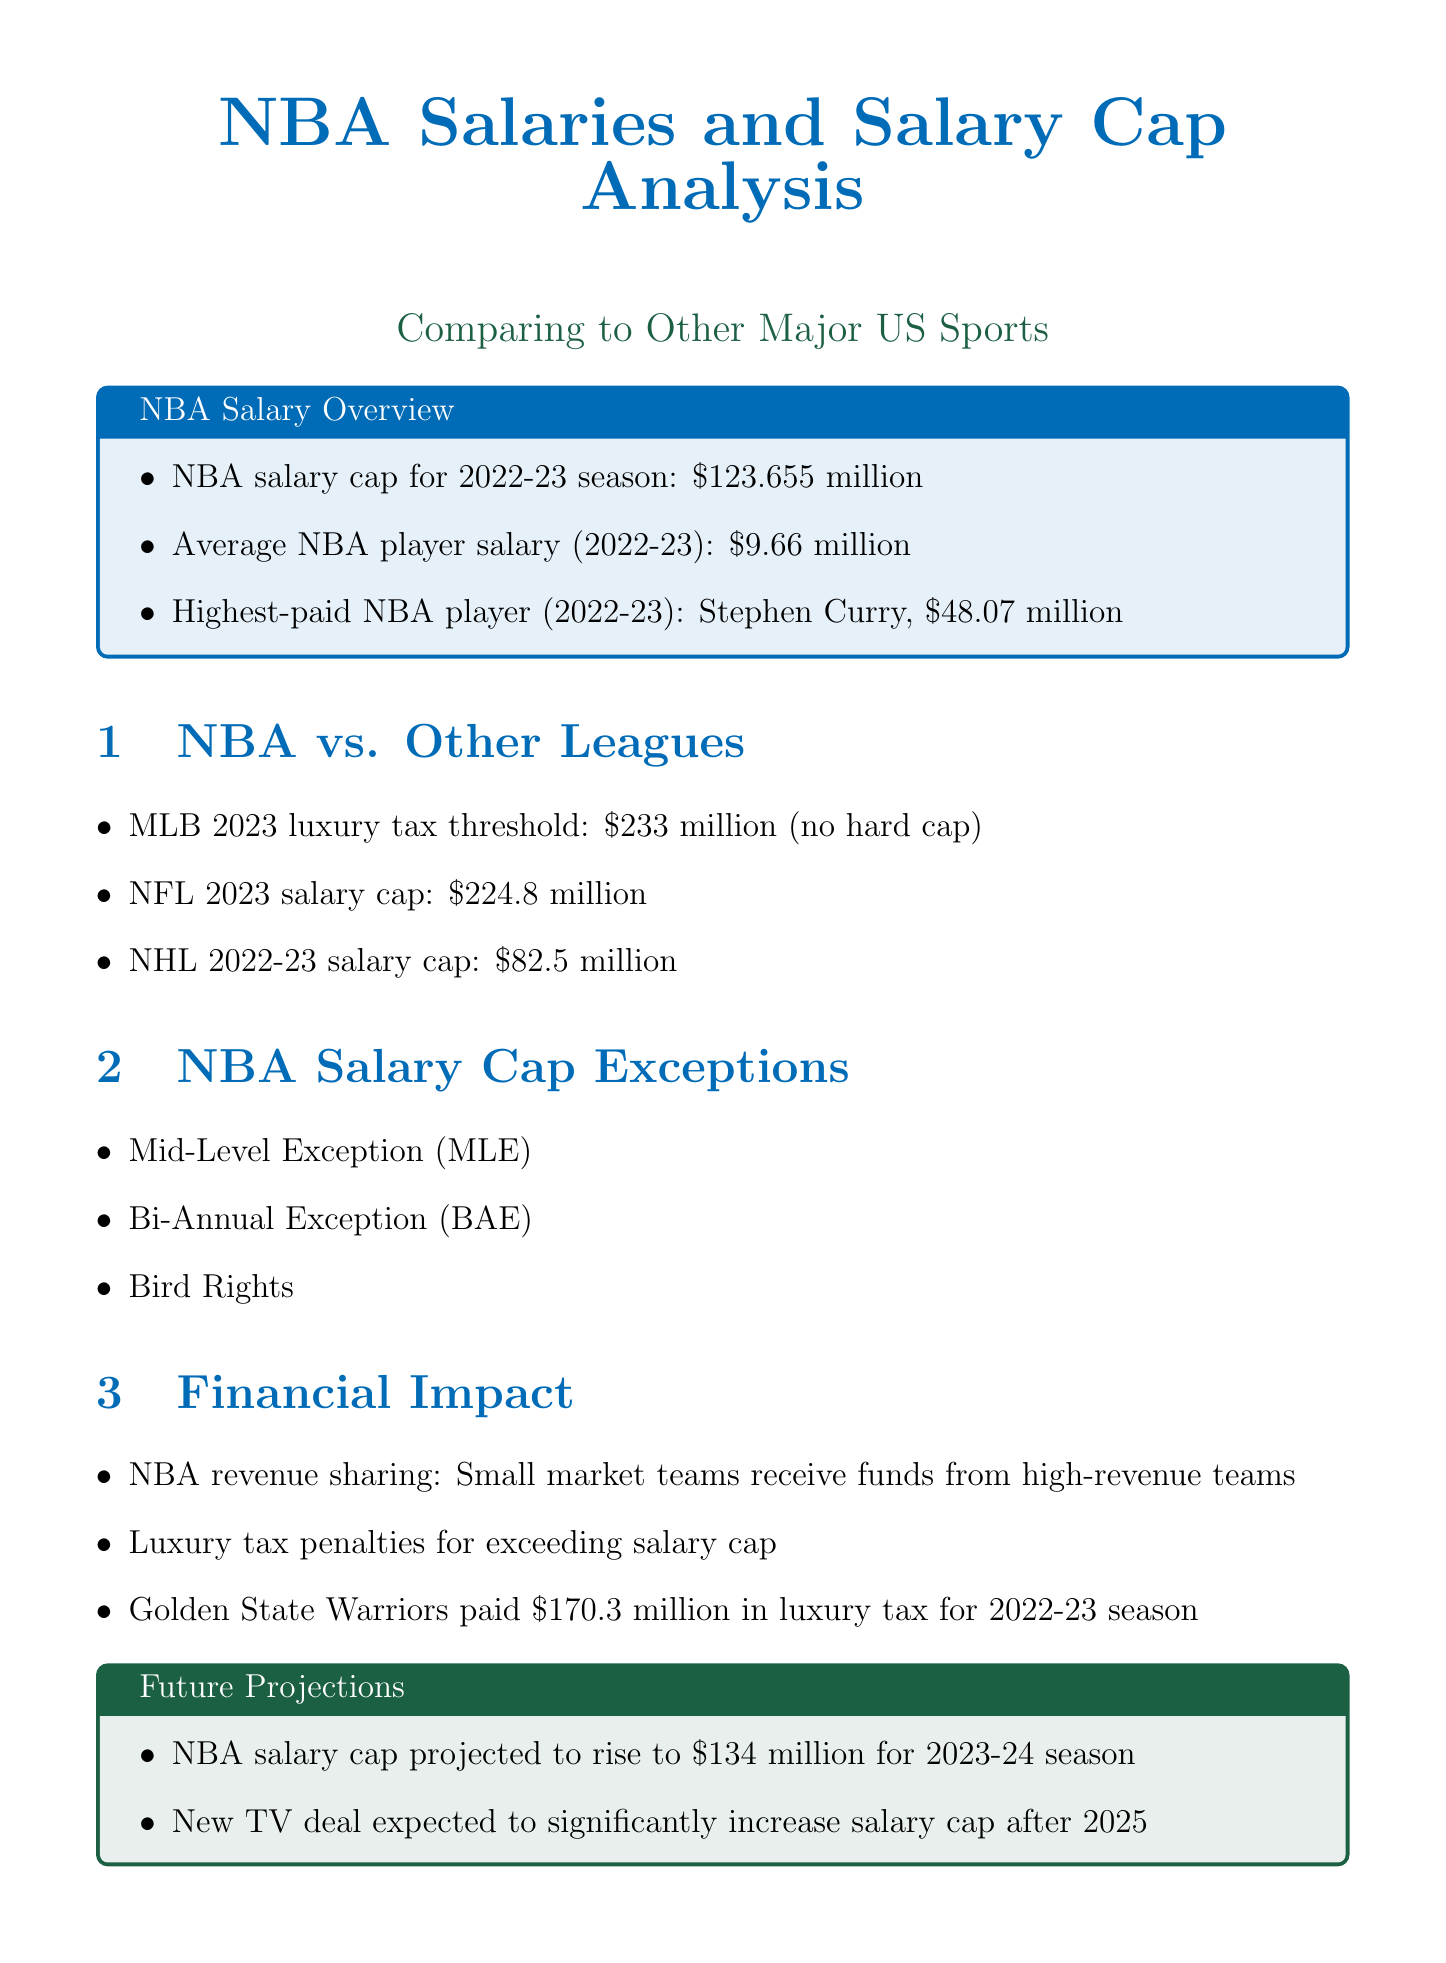What is the NBA salary cap for the 2022-23 season? The document states the NBA salary cap for the 2022-23 season is $123.655 million.
Answer: $123.655 million Who is the highest-paid NBA player for the 2022-23 season? According to the document, the highest-paid NBA player for the 2022-23 season is Stephen Curry.
Answer: Stephen Curry What is the average salary of an NBA player for the 2022-23 season? The average NBA player salary for the 2022-23 season is mentioned as $9.66 million.
Answer: $9.66 million What is the MLB luxury tax threshold for 2023? The document indicates that the MLB 2023 luxury tax threshold is $233 million.
Answer: $233 million Which NBA team paid the most in luxury tax for the 2022-23 season? The document notes that the Golden State Warriors paid $170.3 million in luxury tax for the 2022-23 season.
Answer: Golden State Warriors How much is the projected NBA salary cap for the 2023-24 season? The document projects that the NBA salary cap will rise to $134 million for the 2023-24 season.
Answer: $134 million What are Bird Rights? Bird Rights are listed in the document as one of the NBA salary cap exceptions.
Answer: Bird Rights What is the NFL salary cap for 2023? The document states that the NFL salary cap for 2023 is $224.8 million.
Answer: $224.8 million What financial strategy helps small market NBA teams? The document describes that NBA revenue sharing helps small market teams receive funds from high-revenue teams.
Answer: Revenue sharing 